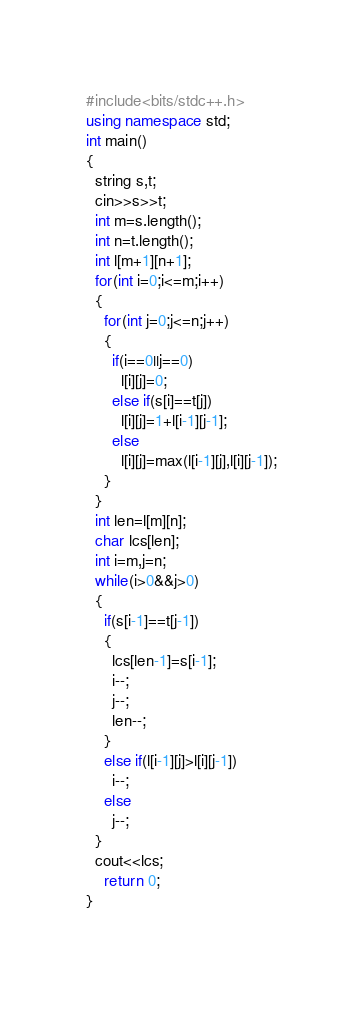Convert code to text. <code><loc_0><loc_0><loc_500><loc_500><_C++_>#include<bits/stdc++.h>
using namespace std;
int main()
{
  string s,t;
  cin>>s>>t;
  int m=s.length();
  int n=t.length();
  int l[m+1][n+1];
  for(int i=0;i<=m;i++)
  {
    for(int j=0;j<=n;j++)
    {
      if(i==0||j==0)
        l[i][j]=0;
      else if(s[i]==t[j])
        l[i][j]=1+l[i-1][j-1];
      else
        l[i][j]=max(l[i-1][j],l[i][j-1]);
    }
  }
  int len=l[m][n];
  char lcs[len];
  int i=m,j=n;
  while(i>0&&j>0)
  {
    if(s[i-1]==t[j-1])
    {
      lcs[len-1]=s[i-1];
      i--;
      j--;
      len--;
    }
    else if(l[i-1][j]>l[i][j-1])
      i--;
    else
      j--;
  }
  cout<<lcs;
    return 0;
}

  </code> 